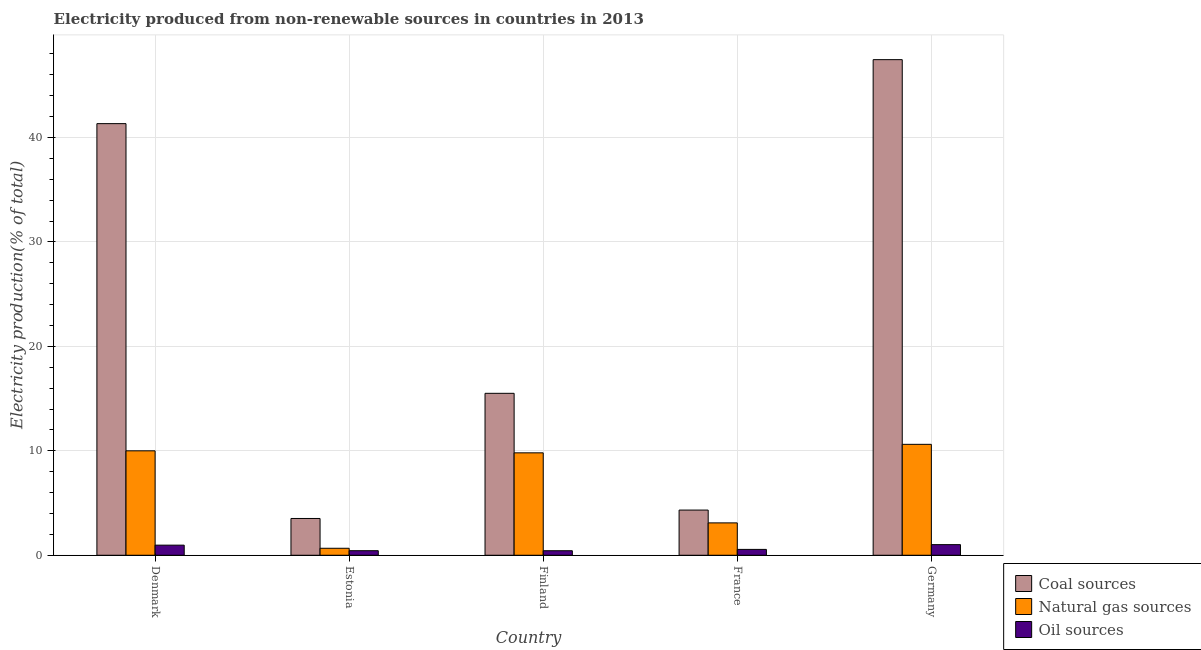Are the number of bars per tick equal to the number of legend labels?
Make the answer very short. Yes. Are the number of bars on each tick of the X-axis equal?
Your answer should be very brief. Yes. How many bars are there on the 5th tick from the left?
Provide a short and direct response. 3. How many bars are there on the 1st tick from the right?
Offer a terse response. 3. What is the percentage of electricity produced by oil sources in Germany?
Your answer should be very brief. 1.02. Across all countries, what is the maximum percentage of electricity produced by coal?
Keep it short and to the point. 47.45. Across all countries, what is the minimum percentage of electricity produced by natural gas?
Offer a terse response. 0.67. In which country was the percentage of electricity produced by natural gas maximum?
Your answer should be very brief. Germany. In which country was the percentage of electricity produced by natural gas minimum?
Your response must be concise. Estonia. What is the total percentage of electricity produced by natural gas in the graph?
Offer a terse response. 34.2. What is the difference between the percentage of electricity produced by coal in Denmark and that in Estonia?
Provide a succinct answer. 37.8. What is the difference between the percentage of electricity produced by natural gas in Estonia and the percentage of electricity produced by oil sources in Germany?
Provide a succinct answer. -0.35. What is the average percentage of electricity produced by natural gas per country?
Ensure brevity in your answer.  6.84. What is the difference between the percentage of electricity produced by coal and percentage of electricity produced by oil sources in Germany?
Provide a short and direct response. 46.43. What is the ratio of the percentage of electricity produced by natural gas in Denmark to that in Germany?
Ensure brevity in your answer.  0.94. What is the difference between the highest and the second highest percentage of electricity produced by oil sources?
Keep it short and to the point. 0.05. What is the difference between the highest and the lowest percentage of electricity produced by natural gas?
Keep it short and to the point. 9.95. In how many countries, is the percentage of electricity produced by natural gas greater than the average percentage of electricity produced by natural gas taken over all countries?
Provide a short and direct response. 3. Is the sum of the percentage of electricity produced by oil sources in Denmark and Finland greater than the maximum percentage of electricity produced by natural gas across all countries?
Your response must be concise. No. What does the 3rd bar from the left in Finland represents?
Make the answer very short. Oil sources. What does the 3rd bar from the right in Finland represents?
Make the answer very short. Coal sources. Is it the case that in every country, the sum of the percentage of electricity produced by coal and percentage of electricity produced by natural gas is greater than the percentage of electricity produced by oil sources?
Provide a short and direct response. Yes. Does the graph contain any zero values?
Ensure brevity in your answer.  No. Does the graph contain grids?
Make the answer very short. Yes. Where does the legend appear in the graph?
Ensure brevity in your answer.  Bottom right. How many legend labels are there?
Provide a succinct answer. 3. What is the title of the graph?
Your response must be concise. Electricity produced from non-renewable sources in countries in 2013. Does "Liquid fuel" appear as one of the legend labels in the graph?
Your answer should be compact. No. What is the label or title of the X-axis?
Offer a very short reply. Country. What is the Electricity production(% of total) in Coal sources in Denmark?
Your answer should be very brief. 41.33. What is the Electricity production(% of total) in Natural gas sources in Denmark?
Give a very brief answer. 10. What is the Electricity production(% of total) in Oil sources in Denmark?
Offer a very short reply. 0.97. What is the Electricity production(% of total) of Coal sources in Estonia?
Offer a very short reply. 3.52. What is the Electricity production(% of total) of Natural gas sources in Estonia?
Keep it short and to the point. 0.67. What is the Electricity production(% of total) of Oil sources in Estonia?
Provide a short and direct response. 0.44. What is the Electricity production(% of total) in Coal sources in Finland?
Offer a terse response. 15.5. What is the Electricity production(% of total) in Natural gas sources in Finland?
Your answer should be compact. 9.81. What is the Electricity production(% of total) of Oil sources in Finland?
Your answer should be very brief. 0.43. What is the Electricity production(% of total) in Coal sources in France?
Your answer should be compact. 4.33. What is the Electricity production(% of total) in Natural gas sources in France?
Keep it short and to the point. 3.1. What is the Electricity production(% of total) of Oil sources in France?
Provide a short and direct response. 0.56. What is the Electricity production(% of total) of Coal sources in Germany?
Offer a very short reply. 47.45. What is the Electricity production(% of total) in Natural gas sources in Germany?
Your response must be concise. 10.62. What is the Electricity production(% of total) of Oil sources in Germany?
Make the answer very short. 1.02. Across all countries, what is the maximum Electricity production(% of total) of Coal sources?
Give a very brief answer. 47.45. Across all countries, what is the maximum Electricity production(% of total) of Natural gas sources?
Your response must be concise. 10.62. Across all countries, what is the maximum Electricity production(% of total) of Oil sources?
Your answer should be compact. 1.02. Across all countries, what is the minimum Electricity production(% of total) of Coal sources?
Your answer should be very brief. 3.52. Across all countries, what is the minimum Electricity production(% of total) of Natural gas sources?
Give a very brief answer. 0.67. Across all countries, what is the minimum Electricity production(% of total) in Oil sources?
Your answer should be compact. 0.43. What is the total Electricity production(% of total) of Coal sources in the graph?
Your response must be concise. 112.13. What is the total Electricity production(% of total) in Natural gas sources in the graph?
Provide a succinct answer. 34.2. What is the total Electricity production(% of total) of Oil sources in the graph?
Offer a very short reply. 3.42. What is the difference between the Electricity production(% of total) in Coal sources in Denmark and that in Estonia?
Provide a succinct answer. 37.8. What is the difference between the Electricity production(% of total) in Natural gas sources in Denmark and that in Estonia?
Your response must be concise. 9.33. What is the difference between the Electricity production(% of total) in Oil sources in Denmark and that in Estonia?
Ensure brevity in your answer.  0.53. What is the difference between the Electricity production(% of total) of Coal sources in Denmark and that in Finland?
Ensure brevity in your answer.  25.82. What is the difference between the Electricity production(% of total) of Natural gas sources in Denmark and that in Finland?
Give a very brief answer. 0.19. What is the difference between the Electricity production(% of total) of Oil sources in Denmark and that in Finland?
Provide a short and direct response. 0.53. What is the difference between the Electricity production(% of total) in Coal sources in Denmark and that in France?
Offer a very short reply. 37. What is the difference between the Electricity production(% of total) of Natural gas sources in Denmark and that in France?
Your response must be concise. 6.9. What is the difference between the Electricity production(% of total) of Oil sources in Denmark and that in France?
Provide a short and direct response. 0.41. What is the difference between the Electricity production(% of total) in Coal sources in Denmark and that in Germany?
Provide a short and direct response. -6.13. What is the difference between the Electricity production(% of total) of Natural gas sources in Denmark and that in Germany?
Your answer should be compact. -0.62. What is the difference between the Electricity production(% of total) in Oil sources in Denmark and that in Germany?
Offer a terse response. -0.05. What is the difference between the Electricity production(% of total) of Coal sources in Estonia and that in Finland?
Your response must be concise. -11.98. What is the difference between the Electricity production(% of total) of Natural gas sources in Estonia and that in Finland?
Your answer should be very brief. -9.14. What is the difference between the Electricity production(% of total) in Oil sources in Estonia and that in Finland?
Offer a very short reply. 0. What is the difference between the Electricity production(% of total) of Coal sources in Estonia and that in France?
Your answer should be compact. -0.81. What is the difference between the Electricity production(% of total) in Natural gas sources in Estonia and that in France?
Give a very brief answer. -2.43. What is the difference between the Electricity production(% of total) of Oil sources in Estonia and that in France?
Make the answer very short. -0.12. What is the difference between the Electricity production(% of total) of Coal sources in Estonia and that in Germany?
Provide a succinct answer. -43.93. What is the difference between the Electricity production(% of total) of Natural gas sources in Estonia and that in Germany?
Offer a terse response. -9.95. What is the difference between the Electricity production(% of total) of Oil sources in Estonia and that in Germany?
Make the answer very short. -0.58. What is the difference between the Electricity production(% of total) in Coal sources in Finland and that in France?
Keep it short and to the point. 11.18. What is the difference between the Electricity production(% of total) of Natural gas sources in Finland and that in France?
Keep it short and to the point. 6.71. What is the difference between the Electricity production(% of total) in Oil sources in Finland and that in France?
Ensure brevity in your answer.  -0.13. What is the difference between the Electricity production(% of total) in Coal sources in Finland and that in Germany?
Give a very brief answer. -31.95. What is the difference between the Electricity production(% of total) of Natural gas sources in Finland and that in Germany?
Give a very brief answer. -0.81. What is the difference between the Electricity production(% of total) in Oil sources in Finland and that in Germany?
Your response must be concise. -0.58. What is the difference between the Electricity production(% of total) of Coal sources in France and that in Germany?
Provide a succinct answer. -43.13. What is the difference between the Electricity production(% of total) in Natural gas sources in France and that in Germany?
Make the answer very short. -7.52. What is the difference between the Electricity production(% of total) in Oil sources in France and that in Germany?
Ensure brevity in your answer.  -0.46. What is the difference between the Electricity production(% of total) of Coal sources in Denmark and the Electricity production(% of total) of Natural gas sources in Estonia?
Offer a terse response. 40.66. What is the difference between the Electricity production(% of total) in Coal sources in Denmark and the Electricity production(% of total) in Oil sources in Estonia?
Give a very brief answer. 40.89. What is the difference between the Electricity production(% of total) in Natural gas sources in Denmark and the Electricity production(% of total) in Oil sources in Estonia?
Offer a terse response. 9.56. What is the difference between the Electricity production(% of total) in Coal sources in Denmark and the Electricity production(% of total) in Natural gas sources in Finland?
Give a very brief answer. 31.52. What is the difference between the Electricity production(% of total) in Coal sources in Denmark and the Electricity production(% of total) in Oil sources in Finland?
Give a very brief answer. 40.89. What is the difference between the Electricity production(% of total) in Natural gas sources in Denmark and the Electricity production(% of total) in Oil sources in Finland?
Your response must be concise. 9.57. What is the difference between the Electricity production(% of total) in Coal sources in Denmark and the Electricity production(% of total) in Natural gas sources in France?
Your answer should be compact. 38.23. What is the difference between the Electricity production(% of total) of Coal sources in Denmark and the Electricity production(% of total) of Oil sources in France?
Your response must be concise. 40.77. What is the difference between the Electricity production(% of total) of Natural gas sources in Denmark and the Electricity production(% of total) of Oil sources in France?
Give a very brief answer. 9.44. What is the difference between the Electricity production(% of total) of Coal sources in Denmark and the Electricity production(% of total) of Natural gas sources in Germany?
Keep it short and to the point. 30.71. What is the difference between the Electricity production(% of total) in Coal sources in Denmark and the Electricity production(% of total) in Oil sources in Germany?
Offer a very short reply. 40.31. What is the difference between the Electricity production(% of total) of Natural gas sources in Denmark and the Electricity production(% of total) of Oil sources in Germany?
Your answer should be compact. 8.98. What is the difference between the Electricity production(% of total) of Coal sources in Estonia and the Electricity production(% of total) of Natural gas sources in Finland?
Provide a short and direct response. -6.28. What is the difference between the Electricity production(% of total) of Coal sources in Estonia and the Electricity production(% of total) of Oil sources in Finland?
Offer a terse response. 3.09. What is the difference between the Electricity production(% of total) of Natural gas sources in Estonia and the Electricity production(% of total) of Oil sources in Finland?
Make the answer very short. 0.24. What is the difference between the Electricity production(% of total) in Coal sources in Estonia and the Electricity production(% of total) in Natural gas sources in France?
Provide a short and direct response. 0.42. What is the difference between the Electricity production(% of total) in Coal sources in Estonia and the Electricity production(% of total) in Oil sources in France?
Provide a succinct answer. 2.96. What is the difference between the Electricity production(% of total) in Natural gas sources in Estonia and the Electricity production(% of total) in Oil sources in France?
Make the answer very short. 0.11. What is the difference between the Electricity production(% of total) of Coal sources in Estonia and the Electricity production(% of total) of Natural gas sources in Germany?
Keep it short and to the point. -7.1. What is the difference between the Electricity production(% of total) in Coal sources in Estonia and the Electricity production(% of total) in Oil sources in Germany?
Your response must be concise. 2.5. What is the difference between the Electricity production(% of total) in Natural gas sources in Estonia and the Electricity production(% of total) in Oil sources in Germany?
Make the answer very short. -0.35. What is the difference between the Electricity production(% of total) of Coal sources in Finland and the Electricity production(% of total) of Natural gas sources in France?
Give a very brief answer. 12.41. What is the difference between the Electricity production(% of total) of Coal sources in Finland and the Electricity production(% of total) of Oil sources in France?
Provide a short and direct response. 14.94. What is the difference between the Electricity production(% of total) in Natural gas sources in Finland and the Electricity production(% of total) in Oil sources in France?
Keep it short and to the point. 9.25. What is the difference between the Electricity production(% of total) of Coal sources in Finland and the Electricity production(% of total) of Natural gas sources in Germany?
Your answer should be compact. 4.88. What is the difference between the Electricity production(% of total) in Coal sources in Finland and the Electricity production(% of total) in Oil sources in Germany?
Your answer should be compact. 14.49. What is the difference between the Electricity production(% of total) of Natural gas sources in Finland and the Electricity production(% of total) of Oil sources in Germany?
Your response must be concise. 8.79. What is the difference between the Electricity production(% of total) of Coal sources in France and the Electricity production(% of total) of Natural gas sources in Germany?
Provide a succinct answer. -6.29. What is the difference between the Electricity production(% of total) of Coal sources in France and the Electricity production(% of total) of Oil sources in Germany?
Provide a succinct answer. 3.31. What is the difference between the Electricity production(% of total) of Natural gas sources in France and the Electricity production(% of total) of Oil sources in Germany?
Your response must be concise. 2.08. What is the average Electricity production(% of total) in Coal sources per country?
Your response must be concise. 22.43. What is the average Electricity production(% of total) in Natural gas sources per country?
Provide a succinct answer. 6.84. What is the average Electricity production(% of total) of Oil sources per country?
Offer a terse response. 0.68. What is the difference between the Electricity production(% of total) in Coal sources and Electricity production(% of total) in Natural gas sources in Denmark?
Your answer should be very brief. 31.33. What is the difference between the Electricity production(% of total) of Coal sources and Electricity production(% of total) of Oil sources in Denmark?
Make the answer very short. 40.36. What is the difference between the Electricity production(% of total) of Natural gas sources and Electricity production(% of total) of Oil sources in Denmark?
Keep it short and to the point. 9.03. What is the difference between the Electricity production(% of total) of Coal sources and Electricity production(% of total) of Natural gas sources in Estonia?
Your answer should be very brief. 2.85. What is the difference between the Electricity production(% of total) of Coal sources and Electricity production(% of total) of Oil sources in Estonia?
Provide a short and direct response. 3.08. What is the difference between the Electricity production(% of total) of Natural gas sources and Electricity production(% of total) of Oil sources in Estonia?
Your answer should be very brief. 0.23. What is the difference between the Electricity production(% of total) in Coal sources and Electricity production(% of total) in Natural gas sources in Finland?
Make the answer very short. 5.7. What is the difference between the Electricity production(% of total) in Coal sources and Electricity production(% of total) in Oil sources in Finland?
Offer a very short reply. 15.07. What is the difference between the Electricity production(% of total) of Natural gas sources and Electricity production(% of total) of Oil sources in Finland?
Your answer should be compact. 9.37. What is the difference between the Electricity production(% of total) of Coal sources and Electricity production(% of total) of Natural gas sources in France?
Keep it short and to the point. 1.23. What is the difference between the Electricity production(% of total) of Coal sources and Electricity production(% of total) of Oil sources in France?
Your response must be concise. 3.77. What is the difference between the Electricity production(% of total) of Natural gas sources and Electricity production(% of total) of Oil sources in France?
Offer a very short reply. 2.54. What is the difference between the Electricity production(% of total) of Coal sources and Electricity production(% of total) of Natural gas sources in Germany?
Ensure brevity in your answer.  36.83. What is the difference between the Electricity production(% of total) of Coal sources and Electricity production(% of total) of Oil sources in Germany?
Offer a very short reply. 46.43. What is the difference between the Electricity production(% of total) of Natural gas sources and Electricity production(% of total) of Oil sources in Germany?
Your answer should be very brief. 9.6. What is the ratio of the Electricity production(% of total) of Coal sources in Denmark to that in Estonia?
Your answer should be very brief. 11.74. What is the ratio of the Electricity production(% of total) in Natural gas sources in Denmark to that in Estonia?
Provide a succinct answer. 14.93. What is the ratio of the Electricity production(% of total) of Oil sources in Denmark to that in Estonia?
Make the answer very short. 2.22. What is the ratio of the Electricity production(% of total) in Coal sources in Denmark to that in Finland?
Offer a terse response. 2.67. What is the ratio of the Electricity production(% of total) of Natural gas sources in Denmark to that in Finland?
Provide a succinct answer. 1.02. What is the ratio of the Electricity production(% of total) of Oil sources in Denmark to that in Finland?
Provide a short and direct response. 2.23. What is the ratio of the Electricity production(% of total) of Coal sources in Denmark to that in France?
Make the answer very short. 9.55. What is the ratio of the Electricity production(% of total) in Natural gas sources in Denmark to that in France?
Make the answer very short. 3.23. What is the ratio of the Electricity production(% of total) in Oil sources in Denmark to that in France?
Provide a succinct answer. 1.73. What is the ratio of the Electricity production(% of total) in Coal sources in Denmark to that in Germany?
Your answer should be very brief. 0.87. What is the ratio of the Electricity production(% of total) in Natural gas sources in Denmark to that in Germany?
Give a very brief answer. 0.94. What is the ratio of the Electricity production(% of total) of Oil sources in Denmark to that in Germany?
Provide a short and direct response. 0.95. What is the ratio of the Electricity production(% of total) of Coal sources in Estonia to that in Finland?
Offer a terse response. 0.23. What is the ratio of the Electricity production(% of total) in Natural gas sources in Estonia to that in Finland?
Give a very brief answer. 0.07. What is the ratio of the Electricity production(% of total) in Oil sources in Estonia to that in Finland?
Provide a short and direct response. 1. What is the ratio of the Electricity production(% of total) in Coal sources in Estonia to that in France?
Offer a terse response. 0.81. What is the ratio of the Electricity production(% of total) in Natural gas sources in Estonia to that in France?
Your response must be concise. 0.22. What is the ratio of the Electricity production(% of total) of Oil sources in Estonia to that in France?
Offer a very short reply. 0.78. What is the ratio of the Electricity production(% of total) in Coal sources in Estonia to that in Germany?
Your answer should be compact. 0.07. What is the ratio of the Electricity production(% of total) of Natural gas sources in Estonia to that in Germany?
Keep it short and to the point. 0.06. What is the ratio of the Electricity production(% of total) in Oil sources in Estonia to that in Germany?
Your answer should be very brief. 0.43. What is the ratio of the Electricity production(% of total) in Coal sources in Finland to that in France?
Offer a very short reply. 3.58. What is the ratio of the Electricity production(% of total) of Natural gas sources in Finland to that in France?
Provide a short and direct response. 3.16. What is the ratio of the Electricity production(% of total) in Oil sources in Finland to that in France?
Ensure brevity in your answer.  0.77. What is the ratio of the Electricity production(% of total) in Coal sources in Finland to that in Germany?
Offer a very short reply. 0.33. What is the ratio of the Electricity production(% of total) of Natural gas sources in Finland to that in Germany?
Your answer should be very brief. 0.92. What is the ratio of the Electricity production(% of total) of Oil sources in Finland to that in Germany?
Your response must be concise. 0.43. What is the ratio of the Electricity production(% of total) in Coal sources in France to that in Germany?
Your response must be concise. 0.09. What is the ratio of the Electricity production(% of total) of Natural gas sources in France to that in Germany?
Your answer should be very brief. 0.29. What is the ratio of the Electricity production(% of total) in Oil sources in France to that in Germany?
Ensure brevity in your answer.  0.55. What is the difference between the highest and the second highest Electricity production(% of total) of Coal sources?
Offer a very short reply. 6.13. What is the difference between the highest and the second highest Electricity production(% of total) in Natural gas sources?
Ensure brevity in your answer.  0.62. What is the difference between the highest and the second highest Electricity production(% of total) in Oil sources?
Your answer should be compact. 0.05. What is the difference between the highest and the lowest Electricity production(% of total) in Coal sources?
Ensure brevity in your answer.  43.93. What is the difference between the highest and the lowest Electricity production(% of total) in Natural gas sources?
Provide a succinct answer. 9.95. What is the difference between the highest and the lowest Electricity production(% of total) of Oil sources?
Your answer should be compact. 0.58. 